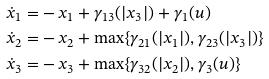Convert formula to latex. <formula><loc_0><loc_0><loc_500><loc_500>\dot { x } _ { 1 } = & - x _ { 1 } + \gamma _ { 1 3 } ( | x _ { 3 } | ) + \gamma _ { 1 } ( u ) \\ \dot { x } _ { 2 } = & - x _ { 2 } + \max \{ \gamma _ { 2 1 } ( | x _ { 1 } | ) , \gamma _ { 2 3 } ( | x _ { 3 } | ) \} \\ \dot { x } _ { 3 } = & - x _ { 3 } + \max \{ \gamma _ { 3 2 } ( | x _ { 2 } | ) , \gamma _ { 3 } ( u ) \}</formula> 